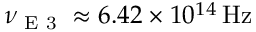<formula> <loc_0><loc_0><loc_500><loc_500>\nu _ { E 3 } \approx 6 . 4 2 \times 1 0 ^ { 1 4 } \, H z</formula> 